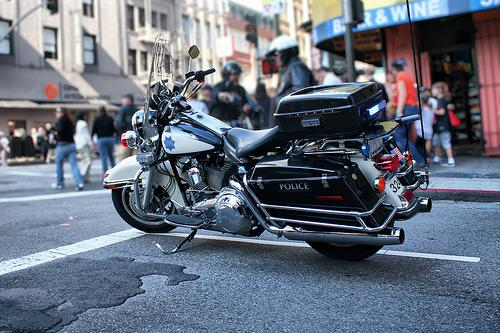What can you say about the condition of the pavement in this image? The pavement has been patched, possibly indicating recent repair work. Can you tell me what type of vehicle is parked in the road? A police motorcycle is parked in the road. Are there any people crossing the street? If yes, how many? Yes, there is at least one person crossing the street. Describe the overall scene captured in the image. The image shows a police motorcycle parked on the road, a child on the sidewalk, a person crossing the street, and a police officer behind the bike. There are also signs for a store and various parts of the motorcycle are visible. Determine the sentiment conveyed in the image. The image portrays a calm and everyday street scene with a police presence, suggesting a sense of security and order. Please enumerate the colors of the lights on the police motorcycle. There is a red light on the front and a blue light on the back of the police motorcycle. How many windows are there on the building in the image? There is a section with windows on the building, but the exact number of windows is not provided. Is the kickstand of the motorcycle up or down? The kickstand of the motorcycle is down. What is the child on the sidewalk doing? There isn't enough information to determine what the child is doing on the sidewalk. What interesting object can you see on the back of the police motorcycle? There is a black box on the back of the police motorcycle. Analyze whether the environment in the image is safe or not. The environment seems safe, with a police officer and a parked motorcycle featuring safety lights. A child is visible on the sidewalk, and people are crossing the street. What is the primary mode of transportation in this image? Motorcycle Are the police lights on the bike green and yellow? The police lights on the bike are red and blue, not green and yellow. List all the objects visible in the image. Police motorcycle, pavement patch, police officer, child, black box, person crossing, police emblem, kickstand, red light, blue light, bike wheel, seat, handlebar, store sign, people walking, stripe, windows, tires, rear light, windshield, man with white helmet. Find the coordinates of the police officer's position in the image. X:262 Y:32 Width:43 Height:43 Analyze any interactions occurring between objects in the image. The police officer is monitoring the people crossing the street, the kickstand is supporting the motorcycle, and the stoplight signals traffic regulations. Is the pavement in perfect condition without any patches? The pavement has been patched, so it is not in perfect condition. What attributes are visible on the police motorcycle? Police emblem, red light, blue light, windshield, kickstand, black box, and tires. Is the police officer riding the motorcycle? The police officer is actually behind the motorcycle, not riding it. Rate the quality of the image on a scale of 1-10. 7 Describe the condition of the road on which the motorcycle is parked. The road has a white stripe and a dark patched area. Segment the police motorcycle in the image by providing its coordinates and dimensions. A possible segmentation: X:62 Y:48 Width:355 Height:355 Is the kickstand of the motorcycle up? The kickstand is actually down, not up. Extract any text visible in the image. There is no clear text visible in the image. State the location of the stoplight in the image and its color. Red light: X:114 Y:125 Width:17 Height:17; Blue light: X:357 Y:142 Width:17 Height:17 Identify the object with coordinates X:431, Y:75, Width:28, Height:28. Child on the sidewalk Describe the scene in the image. A police motorcycle is parked on the road near a patched pavement. A police officer is standing behind the bike, a child is on the sidewalk, and people are crossing the street. Identify the part of the motorcycle that is emitting a red light in the front. X:114 Y:125 Width:17 Height:17 Detect any anomalies or uncommon occurrences in the image. The pavement has been patched, which may be considered an anomaly. Identify the object placed on the back of the police motorcycle. Black box on the back of the bike (X:256 Y:76 Width:125 Height:125) What is the color of the helmet worn by the man near the motorcycle? White (X:261 Y:35 Width:37 Height:37) Is the store sign in the background blue and red? The actual colors of the store sign are not given in the provided information. What emotions does the image evoke? The image evokes feelings of security and caution. Is the child riding on the back of the motorcycle? The child is on the sidewalk, not on the motorcycle. Is the pavement in good condition? Answer yes or no and also provide a reason. No, the pavement has been patched (X:39 Y:258 Width:137 Height:137). 